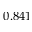Convert formula to latex. <formula><loc_0><loc_0><loc_500><loc_500>0 . 8 4 1</formula> 